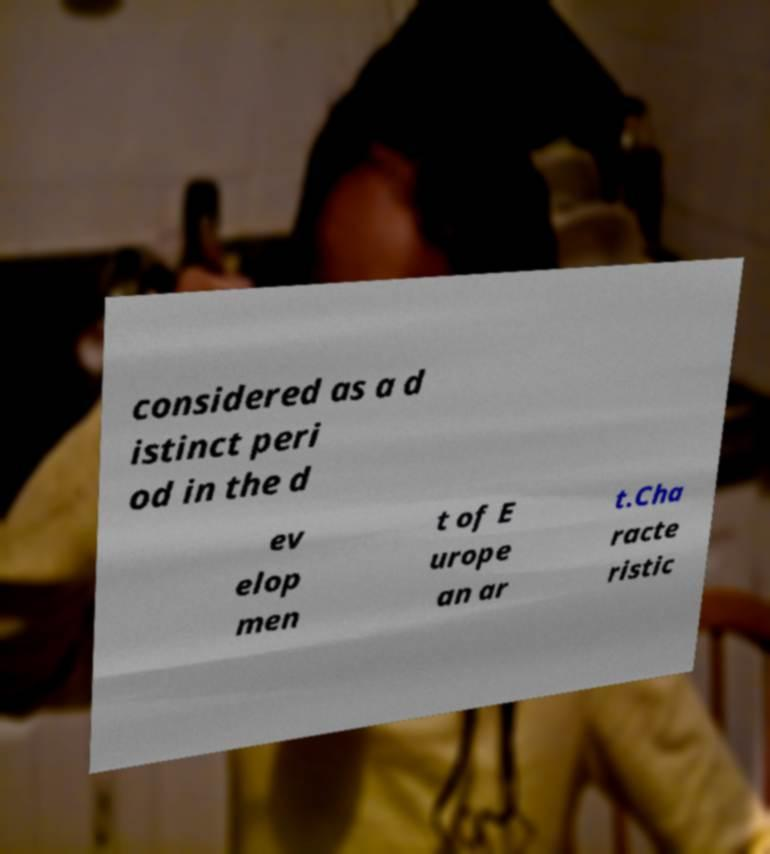Could you extract and type out the text from this image? considered as a d istinct peri od in the d ev elop men t of E urope an ar t.Cha racte ristic 